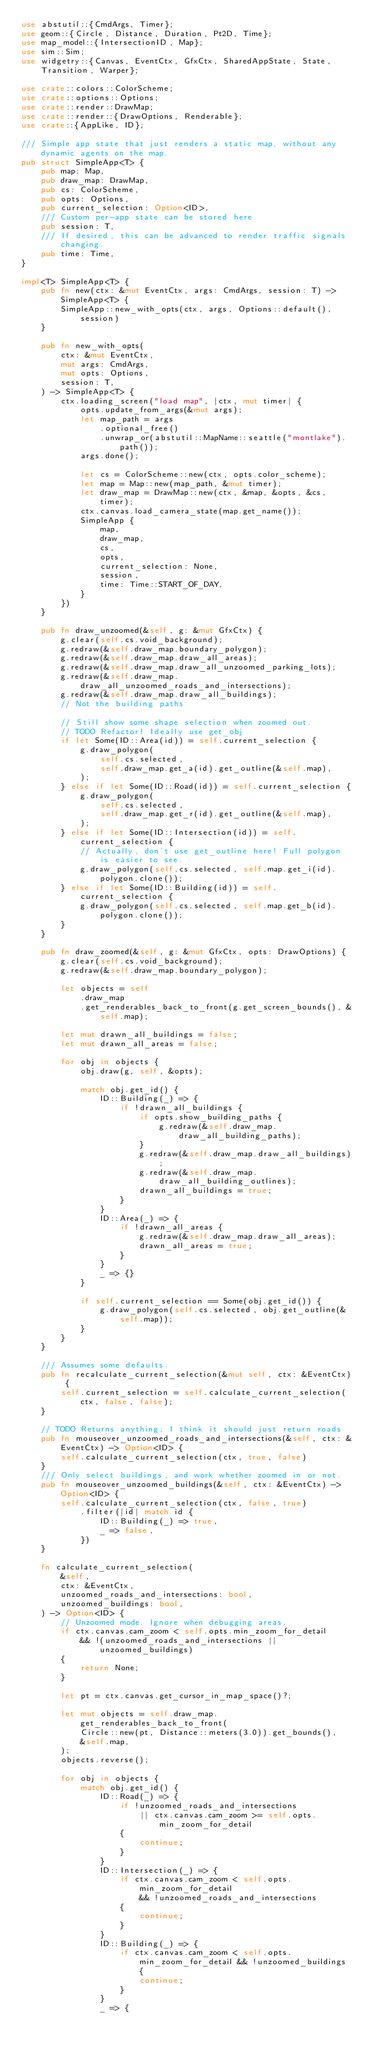<code> <loc_0><loc_0><loc_500><loc_500><_Rust_>use abstutil::{CmdArgs, Timer};
use geom::{Circle, Distance, Duration, Pt2D, Time};
use map_model::{IntersectionID, Map};
use sim::Sim;
use widgetry::{Canvas, EventCtx, GfxCtx, SharedAppState, State, Transition, Warper};

use crate::colors::ColorScheme;
use crate::options::Options;
use crate::render::DrawMap;
use crate::render::{DrawOptions, Renderable};
use crate::{AppLike, ID};

/// Simple app state that just renders a static map, without any dynamic agents on the map.
pub struct SimpleApp<T> {
    pub map: Map,
    pub draw_map: DrawMap,
    pub cs: ColorScheme,
    pub opts: Options,
    pub current_selection: Option<ID>,
    /// Custom per-app state can be stored here
    pub session: T,
    /// If desired, this can be advanced to render traffic signals changing.
    pub time: Time,
}

impl<T> SimpleApp<T> {
    pub fn new(ctx: &mut EventCtx, args: CmdArgs, session: T) -> SimpleApp<T> {
        SimpleApp::new_with_opts(ctx, args, Options::default(), session)
    }

    pub fn new_with_opts(
        ctx: &mut EventCtx,
        mut args: CmdArgs,
        mut opts: Options,
        session: T,
    ) -> SimpleApp<T> {
        ctx.loading_screen("load map", |ctx, mut timer| {
            opts.update_from_args(&mut args);
            let map_path = args
                .optional_free()
                .unwrap_or(abstutil::MapName::seattle("montlake").path());
            args.done();

            let cs = ColorScheme::new(ctx, opts.color_scheme);
            let map = Map::new(map_path, &mut timer);
            let draw_map = DrawMap::new(ctx, &map, &opts, &cs, timer);
            ctx.canvas.load_camera_state(map.get_name());
            SimpleApp {
                map,
                draw_map,
                cs,
                opts,
                current_selection: None,
                session,
                time: Time::START_OF_DAY,
            }
        })
    }

    pub fn draw_unzoomed(&self, g: &mut GfxCtx) {
        g.clear(self.cs.void_background);
        g.redraw(&self.draw_map.boundary_polygon);
        g.redraw(&self.draw_map.draw_all_areas);
        g.redraw(&self.draw_map.draw_all_unzoomed_parking_lots);
        g.redraw(&self.draw_map.draw_all_unzoomed_roads_and_intersections);
        g.redraw(&self.draw_map.draw_all_buildings);
        // Not the building paths

        // Still show some shape selection when zoomed out.
        // TODO Refactor! Ideally use get_obj
        if let Some(ID::Area(id)) = self.current_selection {
            g.draw_polygon(
                self.cs.selected,
                self.draw_map.get_a(id).get_outline(&self.map),
            );
        } else if let Some(ID::Road(id)) = self.current_selection {
            g.draw_polygon(
                self.cs.selected,
                self.draw_map.get_r(id).get_outline(&self.map),
            );
        } else if let Some(ID::Intersection(id)) = self.current_selection {
            // Actually, don't use get_outline here! Full polygon is easier to see.
            g.draw_polygon(self.cs.selected, self.map.get_i(id).polygon.clone());
        } else if let Some(ID::Building(id)) = self.current_selection {
            g.draw_polygon(self.cs.selected, self.map.get_b(id).polygon.clone());
        }
    }

    pub fn draw_zoomed(&self, g: &mut GfxCtx, opts: DrawOptions) {
        g.clear(self.cs.void_background);
        g.redraw(&self.draw_map.boundary_polygon);

        let objects = self
            .draw_map
            .get_renderables_back_to_front(g.get_screen_bounds(), &self.map);

        let mut drawn_all_buildings = false;
        let mut drawn_all_areas = false;

        for obj in objects {
            obj.draw(g, self, &opts);

            match obj.get_id() {
                ID::Building(_) => {
                    if !drawn_all_buildings {
                        if opts.show_building_paths {
                            g.redraw(&self.draw_map.draw_all_building_paths);
                        }
                        g.redraw(&self.draw_map.draw_all_buildings);
                        g.redraw(&self.draw_map.draw_all_building_outlines);
                        drawn_all_buildings = true;
                    }
                }
                ID::Area(_) => {
                    if !drawn_all_areas {
                        g.redraw(&self.draw_map.draw_all_areas);
                        drawn_all_areas = true;
                    }
                }
                _ => {}
            }

            if self.current_selection == Some(obj.get_id()) {
                g.draw_polygon(self.cs.selected, obj.get_outline(&self.map));
            }
        }
    }

    /// Assumes some defaults.
    pub fn recalculate_current_selection(&mut self, ctx: &EventCtx) {
        self.current_selection = self.calculate_current_selection(ctx, false, false);
    }

    // TODO Returns anything; I think it should just return roads
    pub fn mouseover_unzoomed_roads_and_intersections(&self, ctx: &EventCtx) -> Option<ID> {
        self.calculate_current_selection(ctx, true, false)
    }
    /// Only select buildings, and work whether zoomed in or not.
    pub fn mouseover_unzoomed_buildings(&self, ctx: &EventCtx) -> Option<ID> {
        self.calculate_current_selection(ctx, false, true)
            .filter(|id| match id {
                ID::Building(_) => true,
                _ => false,
            })
    }

    fn calculate_current_selection(
        &self,
        ctx: &EventCtx,
        unzoomed_roads_and_intersections: bool,
        unzoomed_buildings: bool,
    ) -> Option<ID> {
        // Unzoomed mode. Ignore when debugging areas.
        if ctx.canvas.cam_zoom < self.opts.min_zoom_for_detail
            && !(unzoomed_roads_and_intersections || unzoomed_buildings)
        {
            return None;
        }

        let pt = ctx.canvas.get_cursor_in_map_space()?;

        let mut objects = self.draw_map.get_renderables_back_to_front(
            Circle::new(pt, Distance::meters(3.0)).get_bounds(),
            &self.map,
        );
        objects.reverse();

        for obj in objects {
            match obj.get_id() {
                ID::Road(_) => {
                    if !unzoomed_roads_and_intersections
                        || ctx.canvas.cam_zoom >= self.opts.min_zoom_for_detail
                    {
                        continue;
                    }
                }
                ID::Intersection(_) => {
                    if ctx.canvas.cam_zoom < self.opts.min_zoom_for_detail
                        && !unzoomed_roads_and_intersections
                    {
                        continue;
                    }
                }
                ID::Building(_) => {
                    if ctx.canvas.cam_zoom < self.opts.min_zoom_for_detail && !unzoomed_buildings {
                        continue;
                    }
                }
                _ => {</code> 